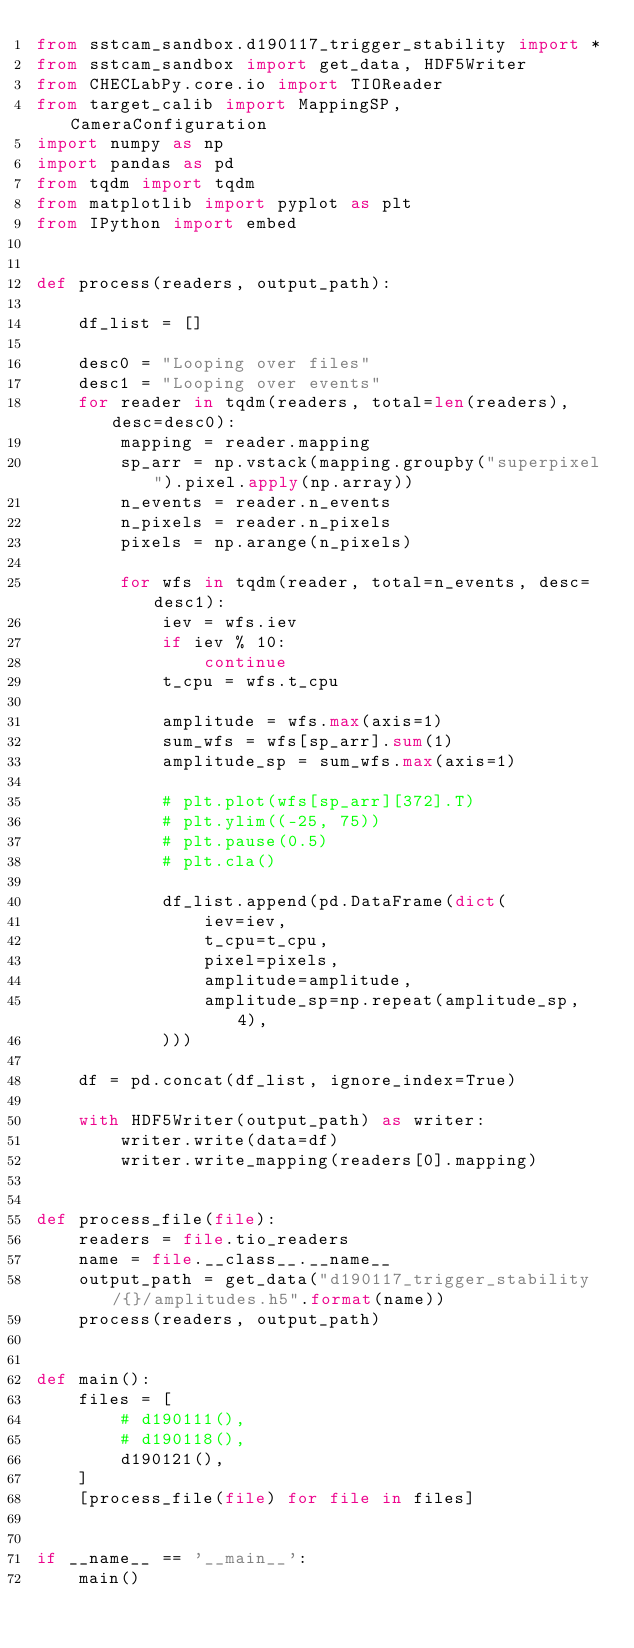<code> <loc_0><loc_0><loc_500><loc_500><_Python_>from sstcam_sandbox.d190117_trigger_stability import *
from sstcam_sandbox import get_data, HDF5Writer
from CHECLabPy.core.io import TIOReader
from target_calib import MappingSP, CameraConfiguration
import numpy as np
import pandas as pd
from tqdm import tqdm
from matplotlib import pyplot as plt
from IPython import embed


def process(readers, output_path):

    df_list = []

    desc0 = "Looping over files"
    desc1 = "Looping over events"
    for reader in tqdm(readers, total=len(readers), desc=desc0):
        mapping = reader.mapping
        sp_arr = np.vstack(mapping.groupby("superpixel").pixel.apply(np.array))
        n_events = reader.n_events
        n_pixels = reader.n_pixels
        pixels = np.arange(n_pixels)

        for wfs in tqdm(reader, total=n_events, desc=desc1):
            iev = wfs.iev
            if iev % 10:
                continue
            t_cpu = wfs.t_cpu

            amplitude = wfs.max(axis=1)
            sum_wfs = wfs[sp_arr].sum(1)
            amplitude_sp = sum_wfs.max(axis=1)

            # plt.plot(wfs[sp_arr][372].T)
            # plt.ylim((-25, 75))
            # plt.pause(0.5)
            # plt.cla()

            df_list.append(pd.DataFrame(dict(
                iev=iev,
                t_cpu=t_cpu,
                pixel=pixels,
                amplitude=amplitude,
                amplitude_sp=np.repeat(amplitude_sp, 4),
            )))

    df = pd.concat(df_list, ignore_index=True)

    with HDF5Writer(output_path) as writer:
        writer.write(data=df)
        writer.write_mapping(readers[0].mapping)


def process_file(file):
    readers = file.tio_readers
    name = file.__class__.__name__
    output_path = get_data("d190117_trigger_stability/{}/amplitudes.h5".format(name))
    process(readers, output_path)


def main():
    files = [
        # d190111(),
        # d190118(),
        d190121(),
    ]
    [process_file(file) for file in files]


if __name__ == '__main__':
    main()
</code> 